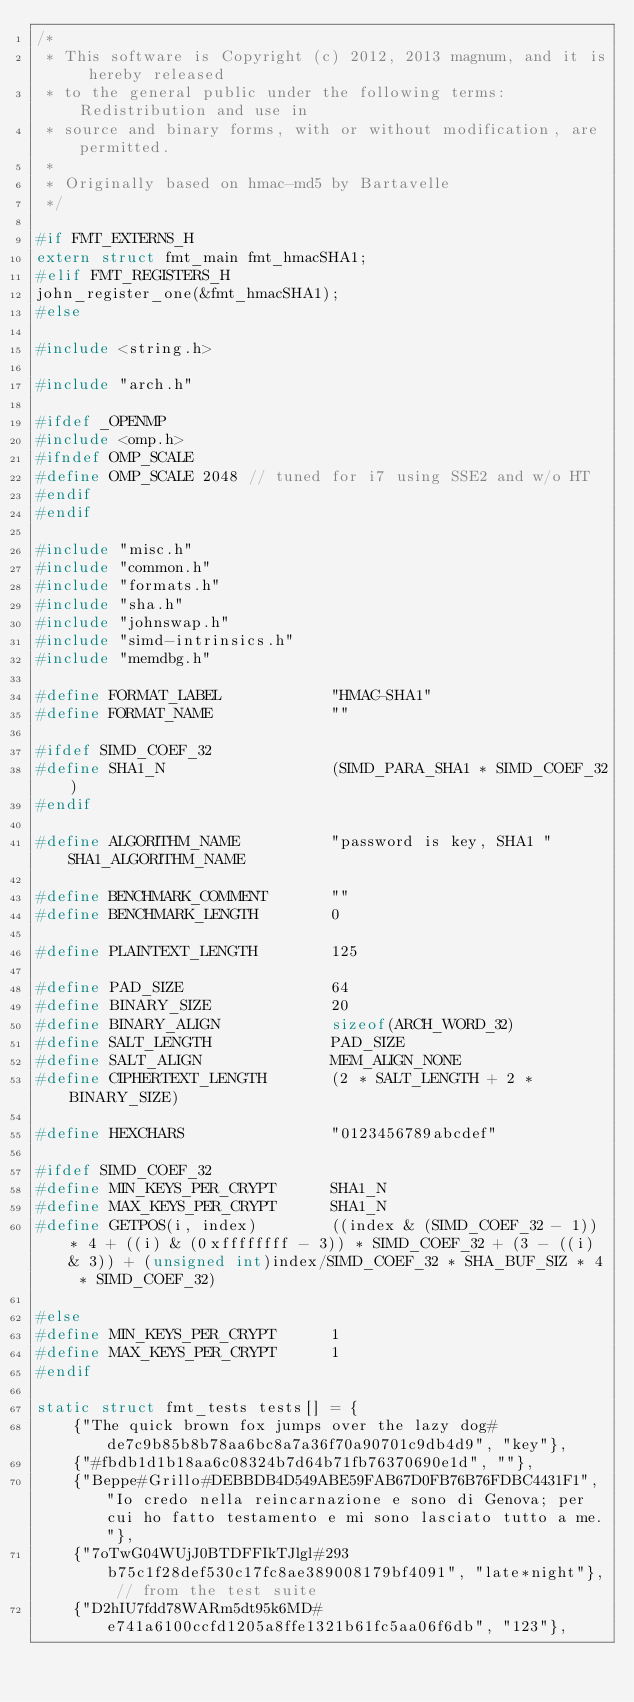Convert code to text. <code><loc_0><loc_0><loc_500><loc_500><_C_>/*
 * This software is Copyright (c) 2012, 2013 magnum, and it is hereby released
 * to the general public under the following terms:  Redistribution and use in
 * source and binary forms, with or without modification, are permitted.
 *
 * Originally based on hmac-md5 by Bartavelle
 */

#if FMT_EXTERNS_H
extern struct fmt_main fmt_hmacSHA1;
#elif FMT_REGISTERS_H
john_register_one(&fmt_hmacSHA1);
#else

#include <string.h>

#include "arch.h"

#ifdef _OPENMP
#include <omp.h>
#ifndef OMP_SCALE
#define OMP_SCALE 2048 // tuned for i7 using SSE2 and w/o HT
#endif
#endif

#include "misc.h"
#include "common.h"
#include "formats.h"
#include "sha.h"
#include "johnswap.h"
#include "simd-intrinsics.h"
#include "memdbg.h"

#define FORMAT_LABEL            "HMAC-SHA1"
#define FORMAT_NAME             ""

#ifdef SIMD_COEF_32
#define SHA1_N                  (SIMD_PARA_SHA1 * SIMD_COEF_32)
#endif

#define ALGORITHM_NAME          "password is key, SHA1 " SHA1_ALGORITHM_NAME

#define BENCHMARK_COMMENT       ""
#define BENCHMARK_LENGTH        0

#define PLAINTEXT_LENGTH        125

#define PAD_SIZE                64
#define BINARY_SIZE             20
#define BINARY_ALIGN            sizeof(ARCH_WORD_32)
#define SALT_LENGTH             PAD_SIZE
#define SALT_ALIGN              MEM_ALIGN_NONE
#define CIPHERTEXT_LENGTH       (2 * SALT_LENGTH + 2 * BINARY_SIZE)

#define HEXCHARS                "0123456789abcdef"

#ifdef SIMD_COEF_32
#define MIN_KEYS_PER_CRYPT      SHA1_N
#define MAX_KEYS_PER_CRYPT      SHA1_N
#define GETPOS(i, index)        ((index & (SIMD_COEF_32 - 1)) * 4 + ((i) & (0xffffffff - 3)) * SIMD_COEF_32 + (3 - ((i) & 3)) + (unsigned int)index/SIMD_COEF_32 * SHA_BUF_SIZ * 4 * SIMD_COEF_32)

#else
#define MIN_KEYS_PER_CRYPT      1
#define MAX_KEYS_PER_CRYPT      1
#endif

static struct fmt_tests tests[] = {
	{"The quick brown fox jumps over the lazy dog#de7c9b85b8b78aa6bc8a7a36f70a90701c9db4d9", "key"},
	{"#fbdb1d1b18aa6c08324b7d64b71fb76370690e1d", ""},
	{"Beppe#Grillo#DEBBDB4D549ABE59FAB67D0FB76B76FDBC4431F1", "Io credo nella reincarnazione e sono di Genova; per cui ho fatto testamento e mi sono lasciato tutto a me."},
	{"7oTwG04WUjJ0BTDFFIkTJlgl#293b75c1f28def530c17fc8ae389008179bf4091", "late*night"}, // from the test suite
	{"D2hIU7fdd78WARm5dt95k6MD#e741a6100ccfd1205a8ffe1321b61fc5aa06f6db", "123"},</code> 